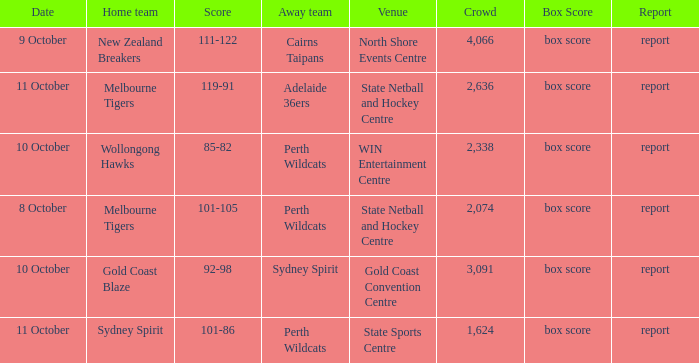What was the crowd size for the game with a score of 101-105? 2074.0. 